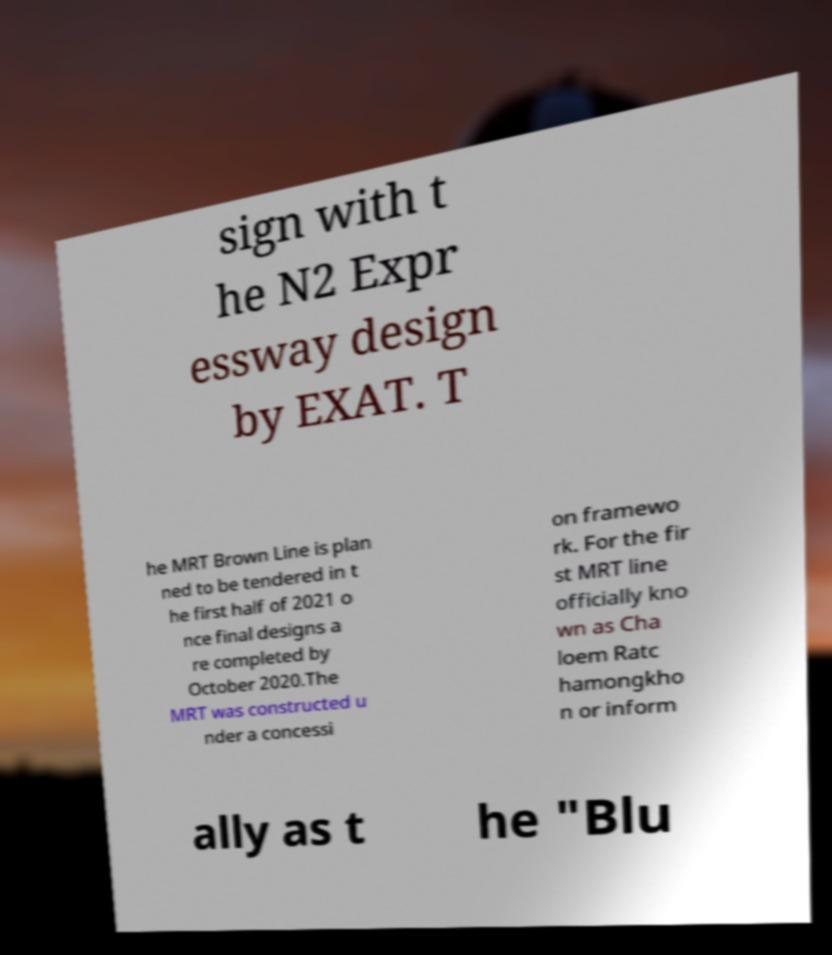Please identify and transcribe the text found in this image. sign with t he N2 Expr essway design by EXAT. T he MRT Brown Line is plan ned to be tendered in t he first half of 2021 o nce final designs a re completed by October 2020.The MRT was constructed u nder a concessi on framewo rk. For the fir st MRT line officially kno wn as Cha loem Ratc hamongkho n or inform ally as t he "Blu 